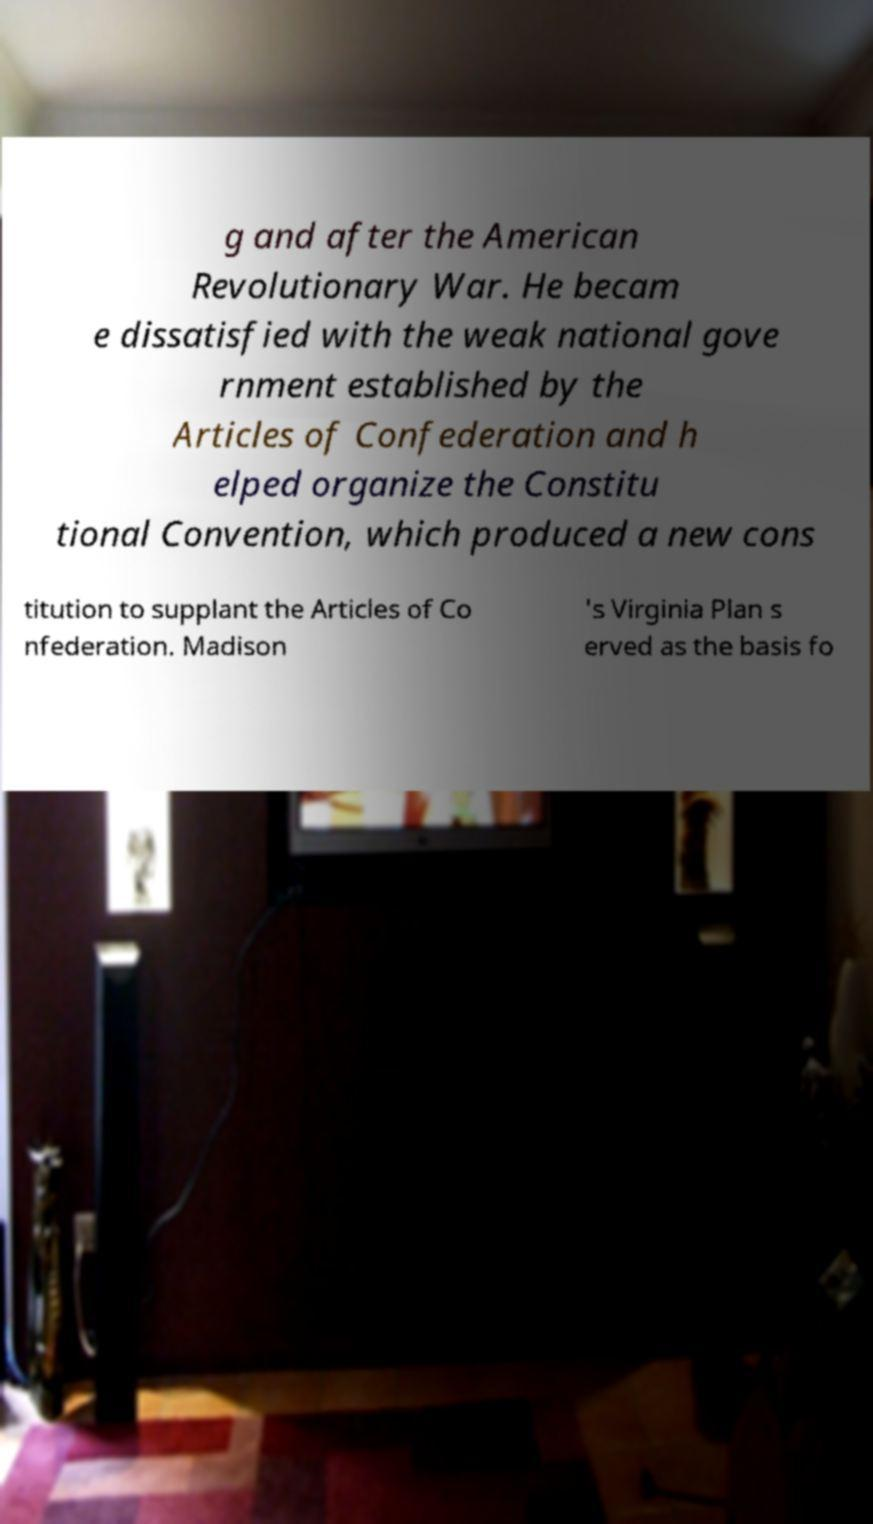Could you assist in decoding the text presented in this image and type it out clearly? g and after the American Revolutionary War. He becam e dissatisfied with the weak national gove rnment established by the Articles of Confederation and h elped organize the Constitu tional Convention, which produced a new cons titution to supplant the Articles of Co nfederation. Madison 's Virginia Plan s erved as the basis fo 